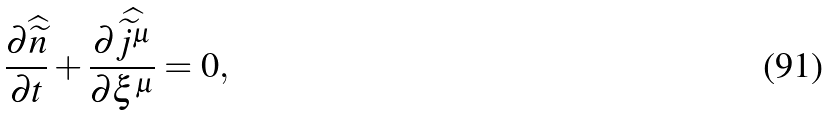Convert formula to latex. <formula><loc_0><loc_0><loc_500><loc_500>\frac { \partial \widehat { \widetilde { n } } } { \partial t } + \frac { \partial \widehat { \widetilde { j } ^ { \mu } } } { \partial \xi ^ { \mu } } = 0 ,</formula> 